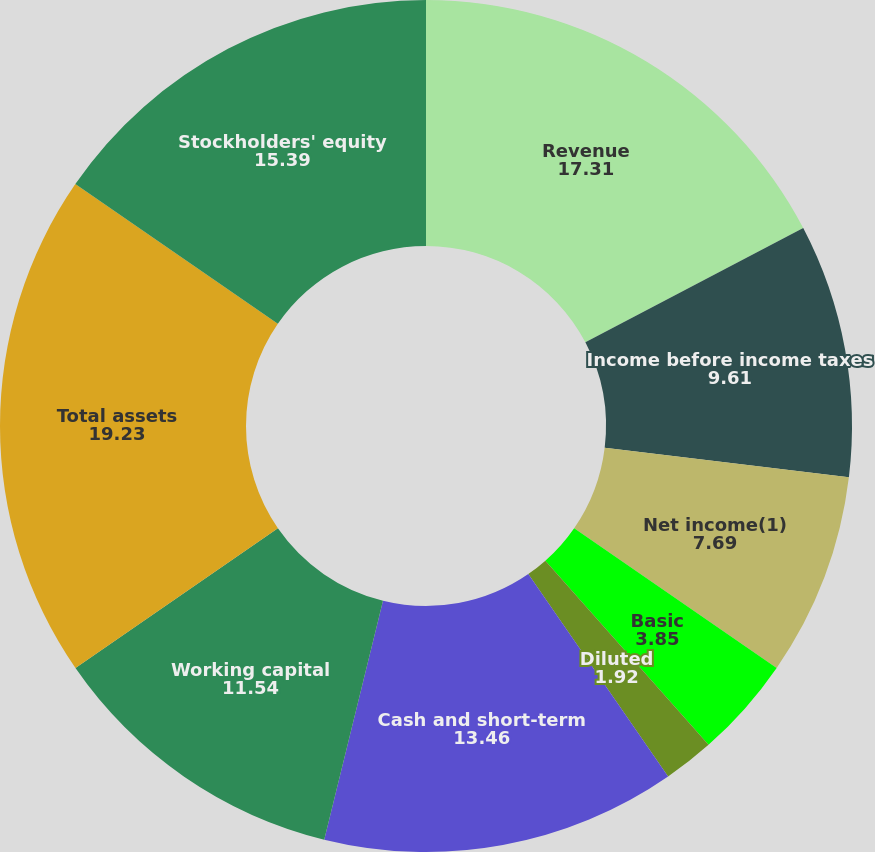Convert chart to OTSL. <chart><loc_0><loc_0><loc_500><loc_500><pie_chart><fcel>Revenue<fcel>Income before income taxes<fcel>Net income(1)<fcel>Basic<fcel>Diluted<fcel>Cash dividends declared per<fcel>Cash and short-term<fcel>Working capital<fcel>Total assets<fcel>Stockholders' equity<nl><fcel>17.31%<fcel>9.61%<fcel>7.69%<fcel>3.85%<fcel>1.92%<fcel>0.0%<fcel>13.46%<fcel>11.54%<fcel>19.23%<fcel>15.39%<nl></chart> 